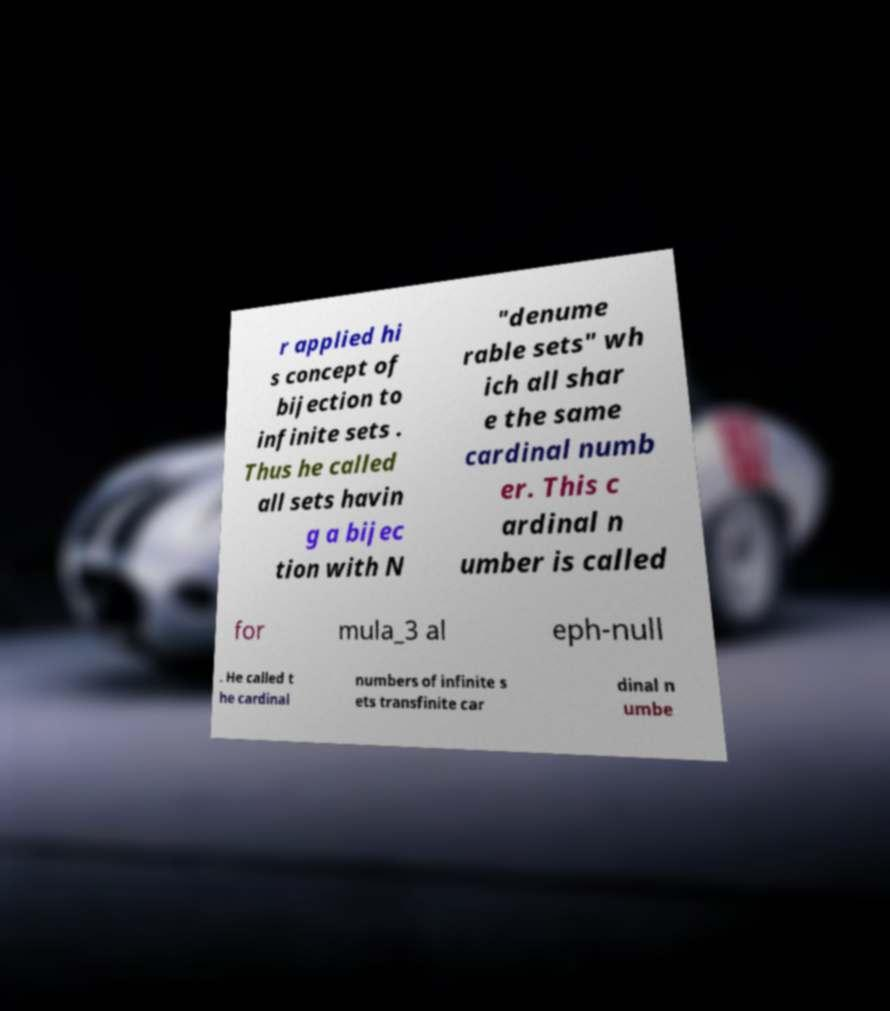For documentation purposes, I need the text within this image transcribed. Could you provide that? r applied hi s concept of bijection to infinite sets . Thus he called all sets havin g a bijec tion with N "denume rable sets" wh ich all shar e the same cardinal numb er. This c ardinal n umber is called for mula_3 al eph-null . He called t he cardinal numbers of infinite s ets transfinite car dinal n umbe 